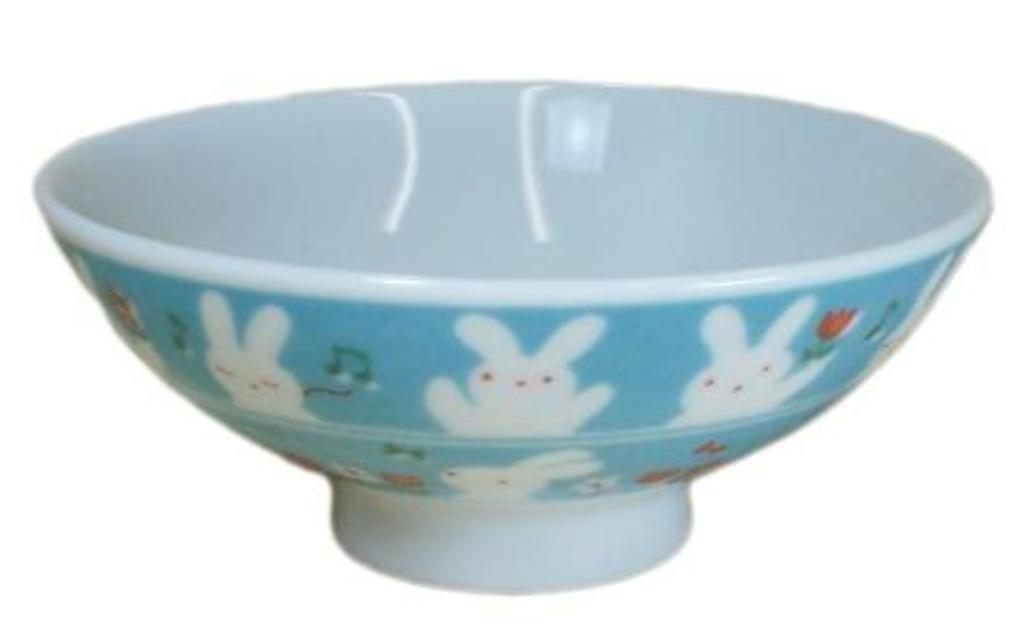What is located in the image? There is a bowl in the image. What color is the background of the image? The background of the image is white. How many words can be seen written on the pig in the image? There is no pig present in the image, and therefore no words can be seen written on it. 